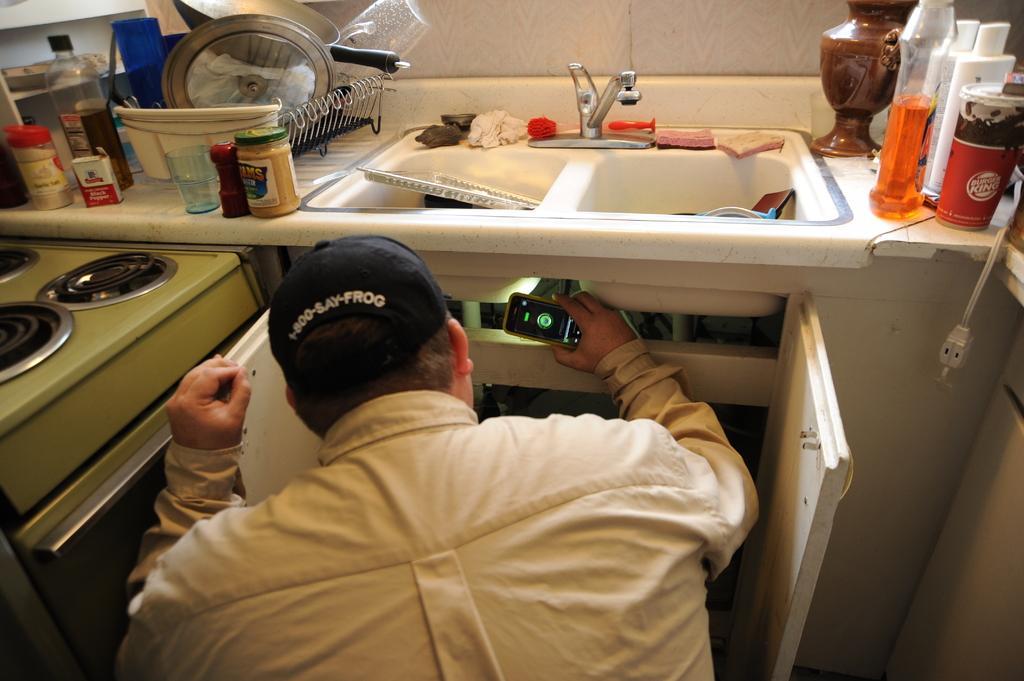Can you describe this image briefly? In this image at the bottom there is one person who is holding a mobile phone and he is looking in to the cupboard, and in front of him there is one cupboard, washbasin, stove. And on the cupboard there are some bottles, utensils, vessels, bottles, clothes and some other objects. 